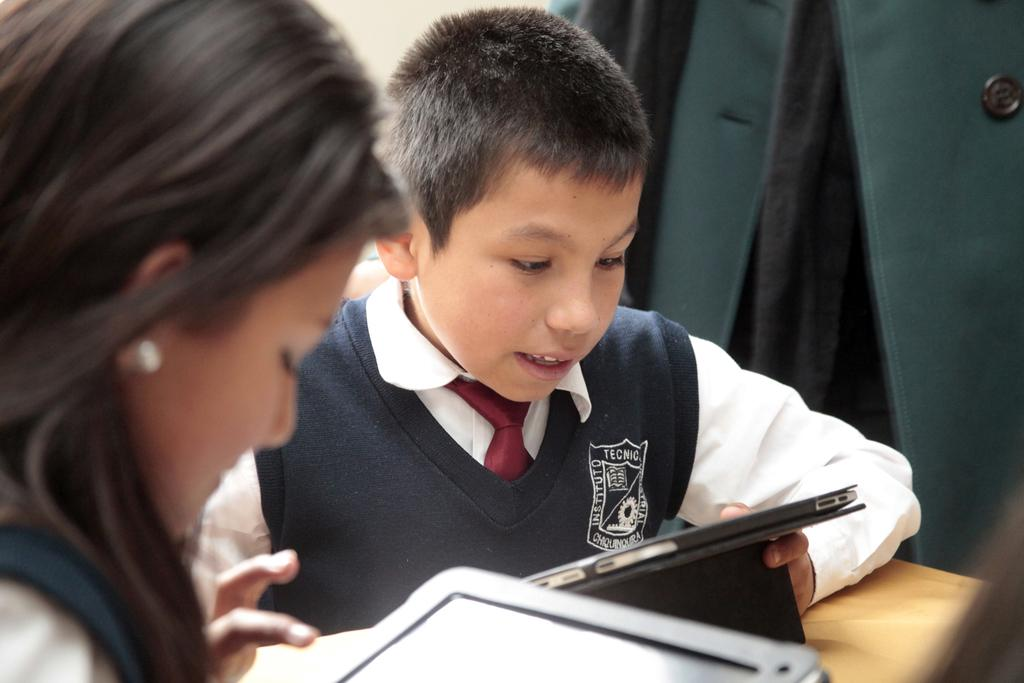Who can be seen in the image? There is a girl and a boy in the image. What are the girl and boy holding? The girl and boy are holding tablets. What can be seen hanging in the background? There is a blazer hanging in the background. What type of furniture is visible in the bottom right corner of the image? There is a wooden table in the bottom right corner of the image. What type of jellyfish can be seen swimming in the image? A: There are no jellyfish present in the image; it features a girl and a boy holding tablets, a blazer hanging in the background, and a wooden table in the bottom right corner. 